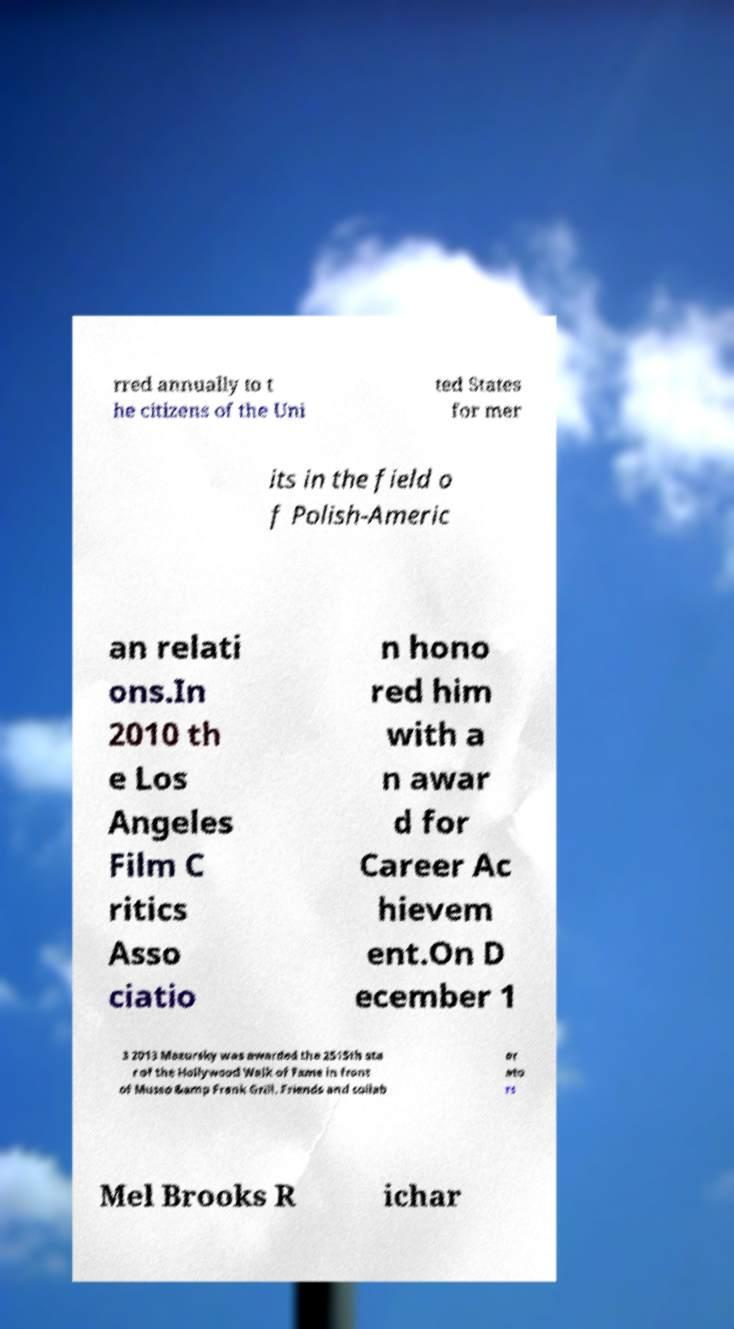Please read and relay the text visible in this image. What does it say? rred annually to t he citizens of the Uni ted States for mer its in the field o f Polish-Americ an relati ons.In 2010 th e Los Angeles Film C ritics Asso ciatio n hono red him with a n awar d for Career Ac hievem ent.On D ecember 1 3 2013 Mazursky was awarded the 2515th sta r of the Hollywood Walk of Fame in front of Musso &amp Frank Grill. Friends and collab or ato rs Mel Brooks R ichar 